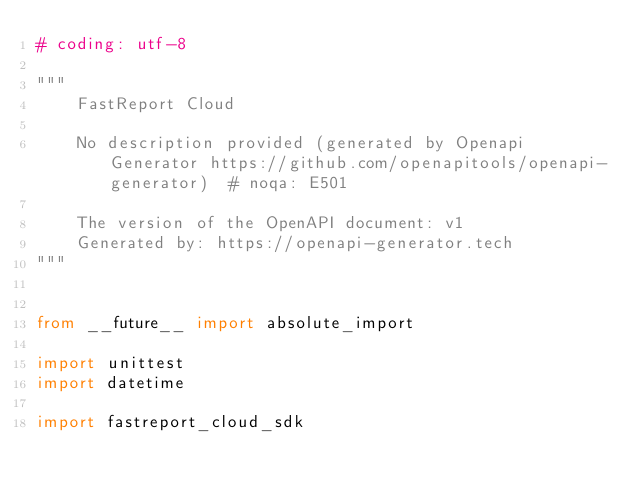<code> <loc_0><loc_0><loc_500><loc_500><_Python_># coding: utf-8

"""
    FastReport Cloud

    No description provided (generated by Openapi Generator https://github.com/openapitools/openapi-generator)  # noqa: E501

    The version of the OpenAPI document: v1
    Generated by: https://openapi-generator.tech
"""


from __future__ import absolute_import

import unittest
import datetime

import fastreport_cloud_sdk</code> 